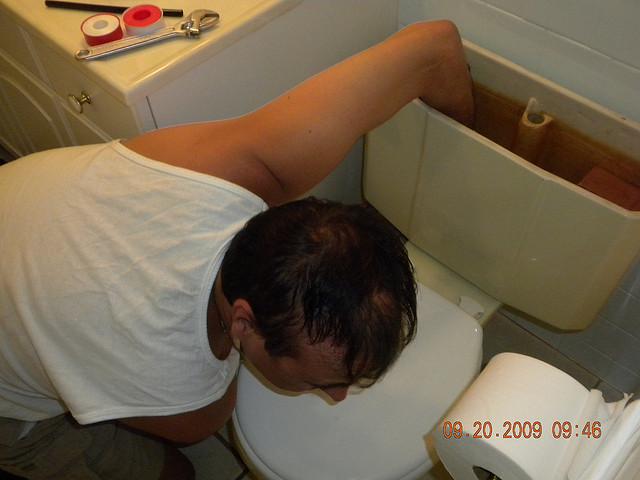What is the date on the photo?
Keep it brief. 09/20/2009. Is the boy small enough to fall in?
Give a very brief answer. No. Is this person a grown up?
Short answer required. Yes. What is the man doing to the toilet?
Concise answer only. Fixing it. What metal tool on the counter called?
Concise answer only. Wrench. 